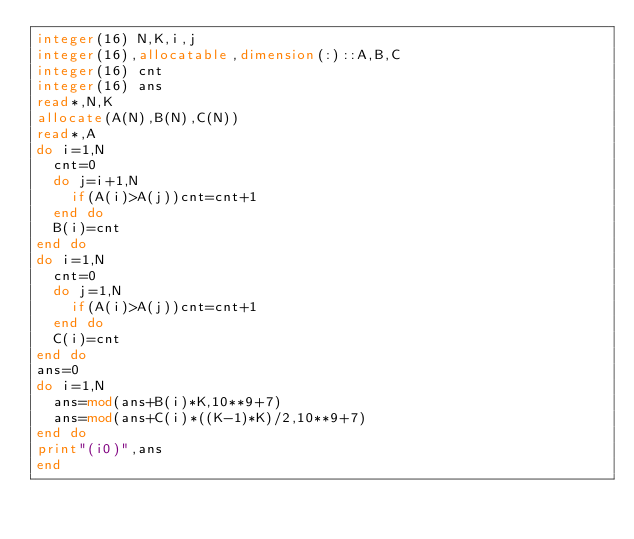<code> <loc_0><loc_0><loc_500><loc_500><_FORTRAN_>integer(16) N,K,i,j
integer(16),allocatable,dimension(:)::A,B,C
integer(16) cnt
integer(16) ans
read*,N,K
allocate(A(N),B(N),C(N))
read*,A
do i=1,N
  cnt=0
  do j=i+1,N
    if(A(i)>A(j))cnt=cnt+1
  end do
  B(i)=cnt
end do
do i=1,N
  cnt=0
  do j=1,N
    if(A(i)>A(j))cnt=cnt+1
  end do
  C(i)=cnt
end do
ans=0
do i=1,N
  ans=mod(ans+B(i)*K,10**9+7)
  ans=mod(ans+C(i)*((K-1)*K)/2,10**9+7)
end do
print"(i0)",ans
end</code> 